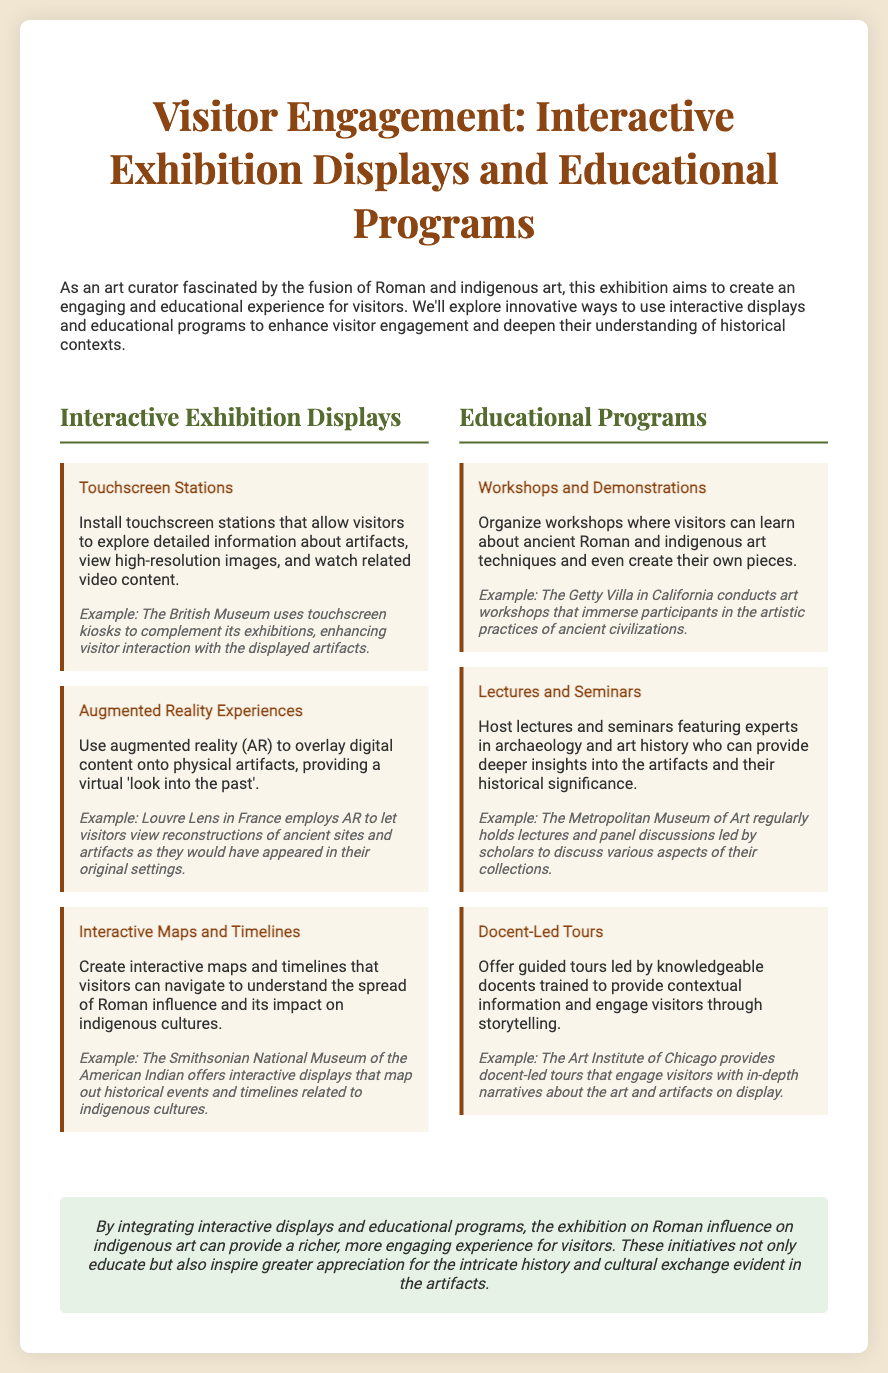What are touchscreen stations used for? Touchscreen stations allow visitors to explore detailed information about artifacts, view high-resolution images, and watch related video content.
Answer: Artifact exploration Which museum uses touchscreen kiosks? The document mentions that the British Museum uses touchscreen kiosks to complement its exhibitions.
Answer: The British Museum What educational program involves creating art pieces? Workshops and demonstrations organize visitors to learn about ancient art techniques and create their own pieces.
Answer: Workshops What type of tours are offered by docents? Docent-led tours are guided tours that provide contextual information and engage visitors through storytelling.
Answer: Guided tours What technology is used to overlay digital content? Augmented reality (AR) is used to overlay digital content onto physical artifacts.
Answer: Augmented reality What is the purpose of interactive maps and timelines? Interactive maps and timelines help visitors understand the spread of Roman influence and its impact on indigenous cultures.
Answer: Understanding influence Who regularly holds lectures about their collections? The Metropolitan Museum of Art regularly hosts lectures and panel discussions led by scholars.
Answer: The Metropolitan Museum of Art What is the exhibition's focus? The exhibition focuses on the influence of Roman art on indigenous cultures.
Answer: Roman influence on indigenous art 